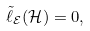Convert formula to latex. <formula><loc_0><loc_0><loc_500><loc_500>\tilde { \ell } _ { \mathcal { E } } ( \mathcal { H } ) = 0 ,</formula> 